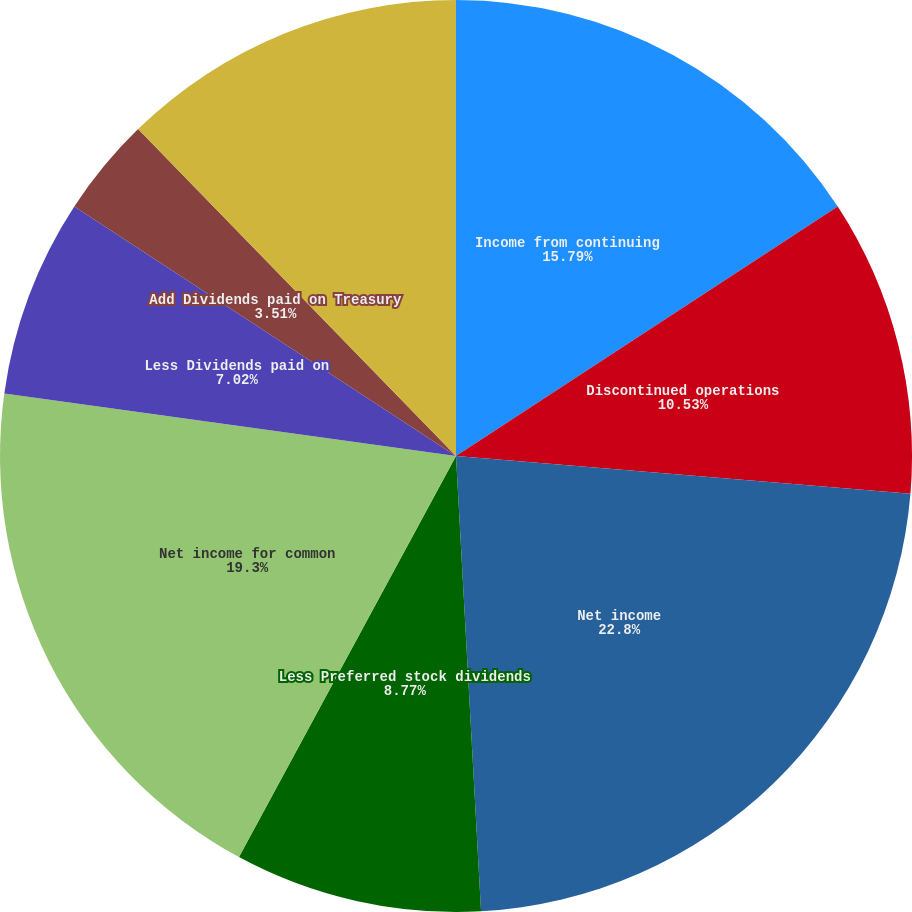<chart> <loc_0><loc_0><loc_500><loc_500><pie_chart><fcel>Income from continuing<fcel>Discontinued operations<fcel>Net income<fcel>Less Preferred stock dividends<fcel>Net income for common<fcel>Less Dividends paid on<fcel>Add Dividends paid on Treasury<fcel>Weighted average common shares<nl><fcel>15.79%<fcel>10.53%<fcel>22.81%<fcel>8.77%<fcel>19.3%<fcel>7.02%<fcel>3.51%<fcel>12.28%<nl></chart> 